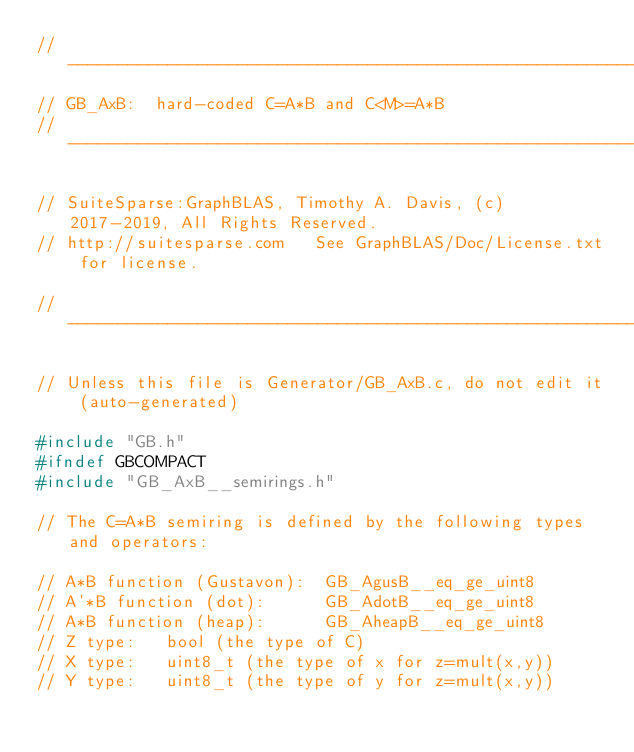<code> <loc_0><loc_0><loc_500><loc_500><_C_>//------------------------------------------------------------------------------
// GB_AxB:  hard-coded C=A*B and C<M>=A*B
//------------------------------------------------------------------------------

// SuiteSparse:GraphBLAS, Timothy A. Davis, (c) 2017-2019, All Rights Reserved.
// http://suitesparse.com   See GraphBLAS/Doc/License.txt for license.

//------------------------------------------------------------------------------

// Unless this file is Generator/GB_AxB.c, do not edit it (auto-generated)

#include "GB.h"
#ifndef GBCOMPACT
#include "GB_AxB__semirings.h"

// The C=A*B semiring is defined by the following types and operators:

// A*B function (Gustavon):  GB_AgusB__eq_ge_uint8
// A'*B function (dot):      GB_AdotB__eq_ge_uint8
// A*B function (heap):      GB_AheapB__eq_ge_uint8
// Z type:   bool (the type of C)
// X type:   uint8_t (the type of x for z=mult(x,y))
// Y type:   uint8_t (the type of y for z=mult(x,y))</code> 